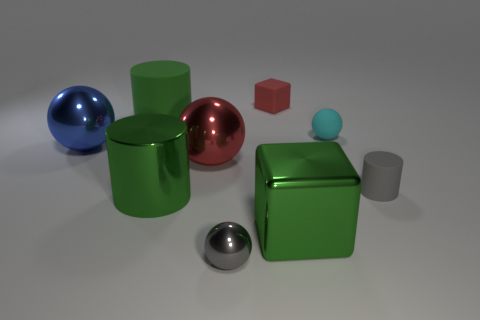Can you explain the lighting direction in the image? The shadows of the objects suggest that the light source is located above and to the right of the scene. The shadows are relatively soft and diffuse, indicating that the light source is not extremely close to the objects, providing an even illumination to the setup. 